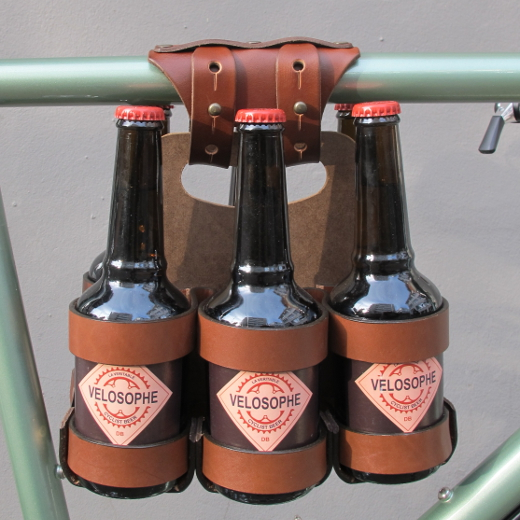Imagine this bike and its accessory in a different context. What scenario comes to mind? Imagine cycling through the scenic vineyards of France on a warm summer day, with the bottles carefully secured in the leather holder clinking softly as you pedal. After an enjoyable ride, you find a spot under an ancient oak tree overlooking the lush green rows of grapevines. You park your bike, take out the chilled beverages, and share them with friends, creating a perfect moment of relaxation and bliss in the heart of wine country. What would be a more casual day-to-day use for this accessory in an urban setting? In an urban setting, this accessory would be perfect for transporting bottled beverages to a picnic in the park or when running errands around the city. It adds convenience and style to your daily bike commutes, whether you're grabbing a drink with friends or enjoying some refreshments while relaxing outdoors. 